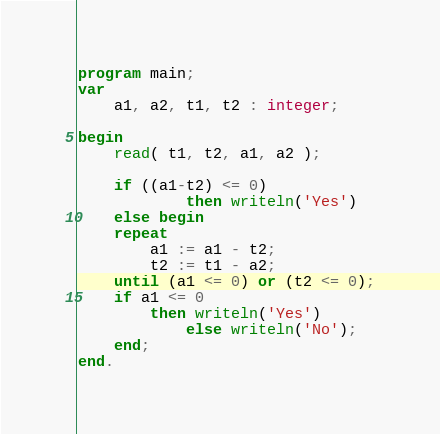Convert code to text. <code><loc_0><loc_0><loc_500><loc_500><_Pascal_>program main;
var
	a1, a2, t1, t2 : integer; 
 
begin
	read( t1, t2, a1, a2 );
    
    if ((a1-t2) <= 0)
        	then writeln('Yes')
    else begin
    repeat
    	a1 := a1 - t2;
        t2 := t1 - a2;
    until (a1 <= 0) or (t2 <= 0);
    if a1 <= 0
    	then writeln('Yes')
        	else writeln('No');
    end;
end.
</code> 